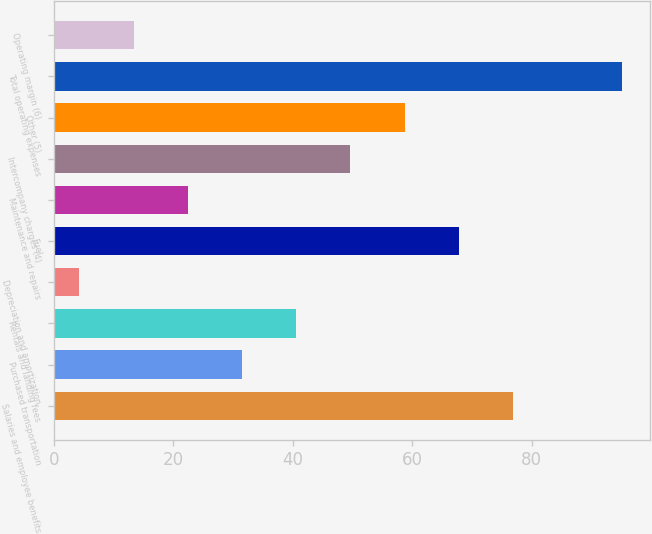Convert chart. <chart><loc_0><loc_0><loc_500><loc_500><bar_chart><fcel>Salaries and employee benefits<fcel>Purchased transportation<fcel>Rentals and landing fees<fcel>Depreciation and amortization<fcel>Fuel<fcel>Maintenance and repairs<fcel>Intercompany charges (4)<fcel>Other (5)<fcel>Total operating expenses<fcel>Operating margin (6)<nl><fcel>76.86<fcel>31.51<fcel>40.58<fcel>4.3<fcel>67.79<fcel>22.44<fcel>49.65<fcel>58.72<fcel>95<fcel>13.37<nl></chart> 